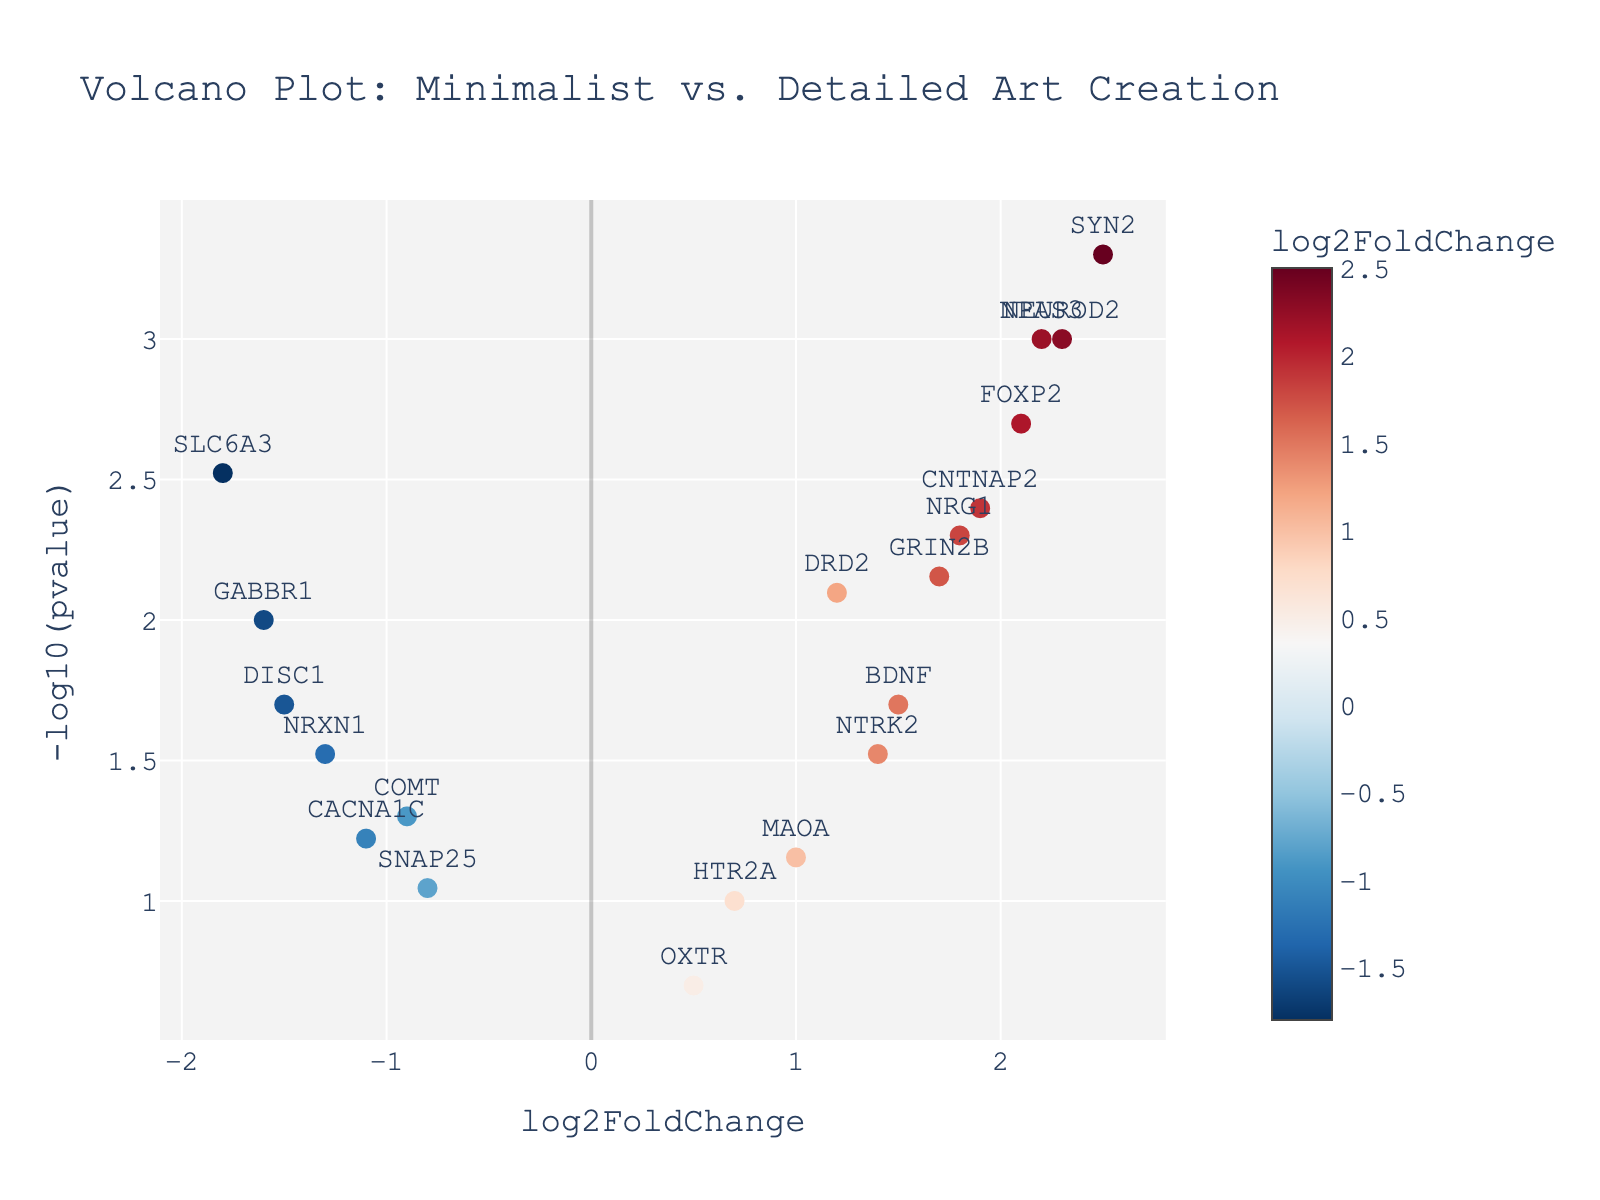What does the x-axis of the plot represent? The x-axis represents the "log2FoldChange,” which indicates the magnitude of change between minimalist and detailed art creation conditions for each gene. A positive value suggests higher expression in minimalist art creation, while a negative value suggests higher expression in detailed art creation.
Answer: log2FoldChange Which gene has the highest -log10(pvalue)? To find the gene with the highest -log10(pvalue), look for the point that is highest on the y-axis. The gene "SYN2" has the highest value.
Answer: SYN2 Which gene has the highest log2FoldChange value? The highest log2FoldChange value corresponds to the farthest point to the right on the x-axis. The gene "SYN2" has the highest log2FoldChange value of 2.5.
Answer: SYN2 How many genes have a p-value less than 0.05? To determine this, we need to count the number of points above the -log10(0.05) threshold on the y-axis. "-log10(0.05) equals 1.301. Counting the points above this threshold, there are 12 genes.
Answer: 12 Which genes have a log2FoldChange greater than 2 and a p-value less than 0.01? We identify points with a log2FoldChange greater than 2 and above the -log10(0.01) threshold on the y-axis. The genes "SYN2," "NPAS3," and "NEUROD2" meet these criteria.
Answer: SYN2, NPAS3, NEUROD2 How does the expression of FOXP2 compare to DRD2 in terms of log2FoldChange and p-value? The log2FoldChange of FOXP2 is 2.1, and its p-value translates to -log10(0.002)=2.70 on the y-axis. The log2FoldChange of DRD2 is 1.2, and its p-value translates to -log10(0.008)=2.10. Thus, FOXP2 has higher log2FoldChange and higher statistical significance compared to DRD2.
Answer: FOXP2 has higher log2FoldChange and higher significance What are the two most statistically significant genes when comparing minimalist and detailed art creation? The most statistically significant genes will have the highest -log10(pvalue). The two highest points on the y-axis are "SYN2" and "NPAS3".
Answer: SYN2, NPAS3 What's the relationship between log2FoldChange and p-value for the gene NRG1? For NRG1, the log2FoldChange is 1.8, implying higher expression under minimalist art creation. The p-value is 0.005, which translates to -log10(0.005)=2.30 on the y-axis, indicating statistical significance.
Answer: Higher expression in minimalist art, statistically significant Which gene shows a significant change in expression with the lowest positive log2FoldChange value? We need to find the gene with the smallest positive log2FoldChange value that is significant. "DRD2" has a log2FoldChange of 1.2 and a p-value translating to -log10(0.008) = 2.10, meeting the significance threshold.
Answer: DRD2 